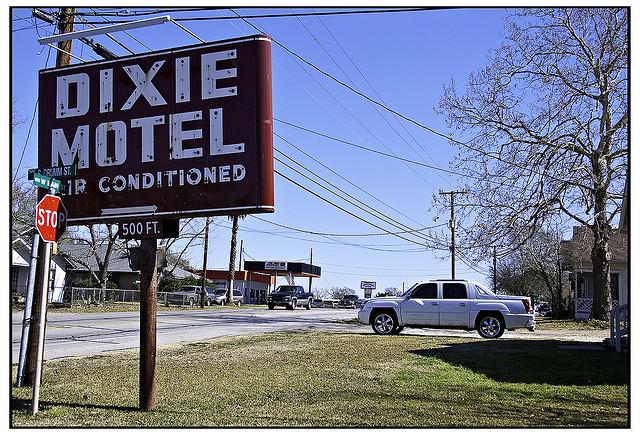Are there any leaves on the tree on the right side of the picture?
Concise answer only. No. What does the sign say?
Keep it brief. Dixie motel. Does the motel have air?
Quick response, please. Yes. Is the Dixie Motel air conditioned?
Quick response, please. Yes. Are the trees green?
Short answer required. No. Is there something creepy about that sign's wording?
Answer briefly. No. 